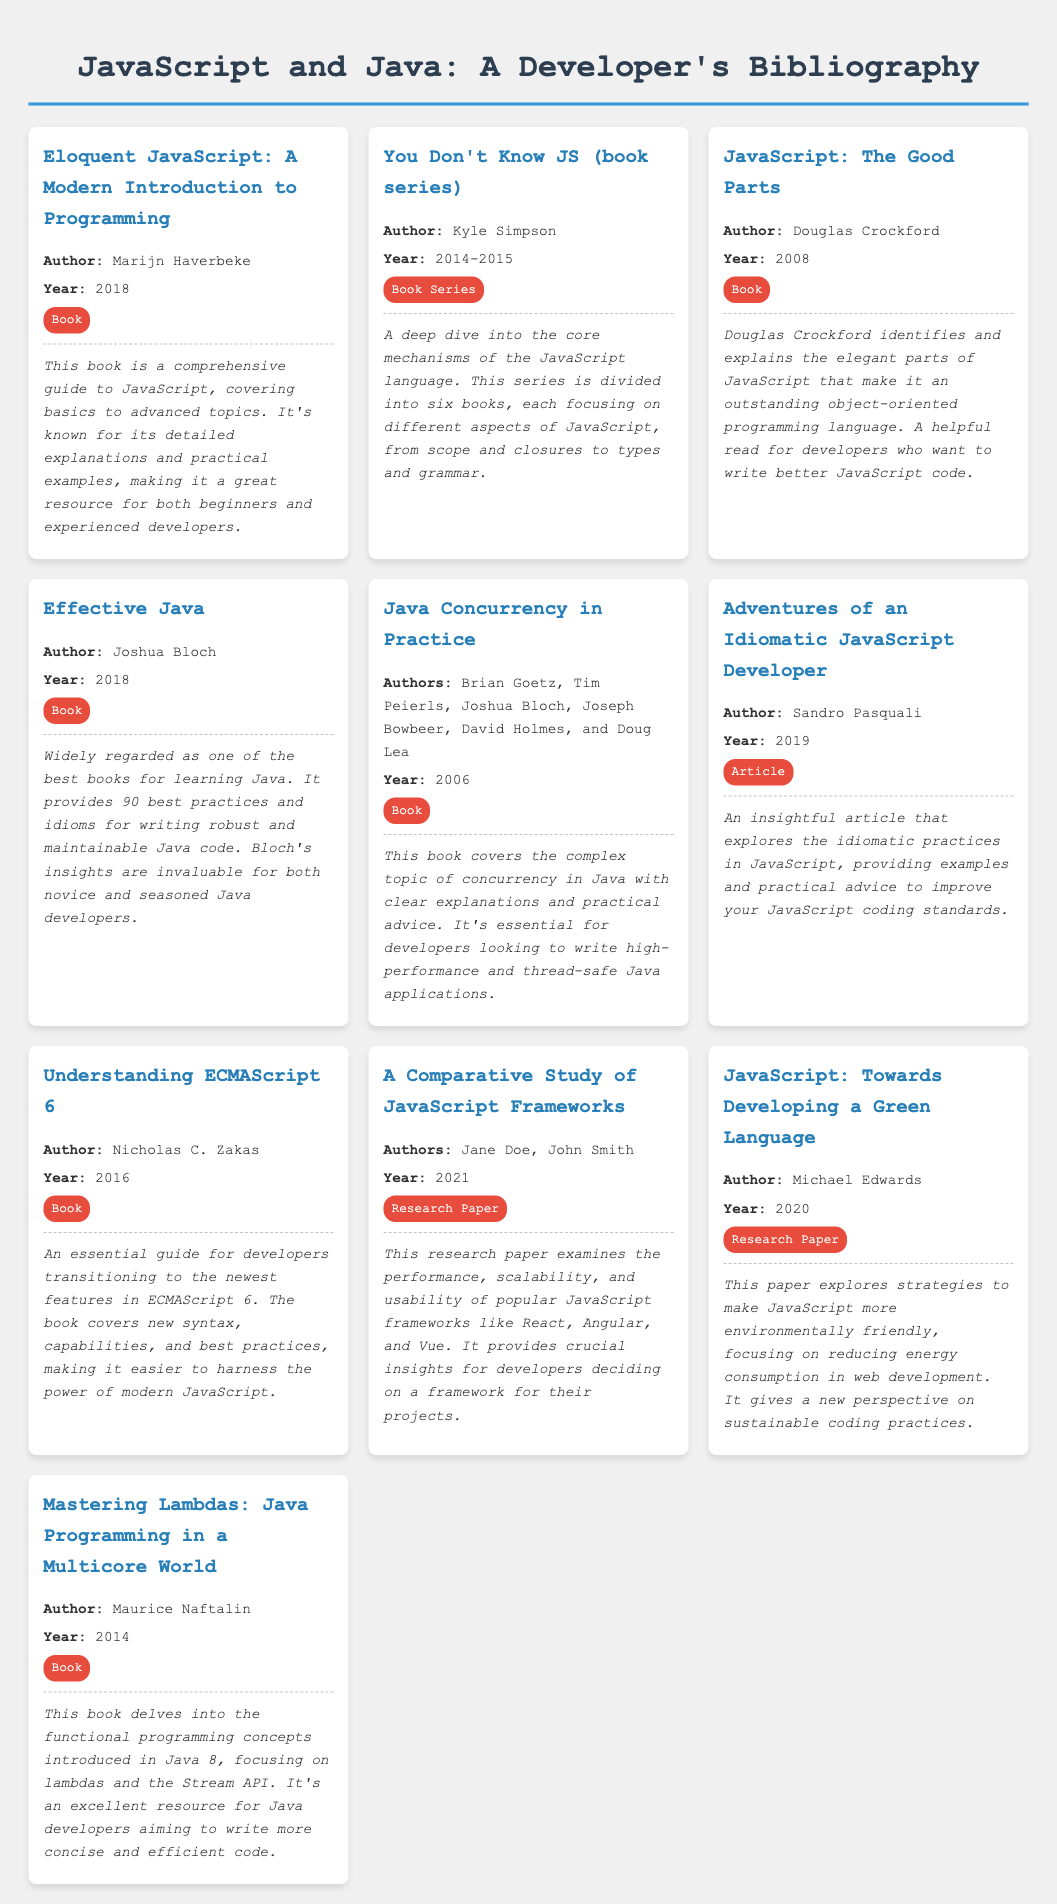What is the title of the book by Marijn Haverbeke? The document lists "Eloquent JavaScript: A Modern Introduction to Programming" as the title by Marijn Haverbeke.
Answer: Eloquent JavaScript: A Modern Introduction to Programming Who is the author of "Effective Java"? The document states that "Effective Java" is authored by Joshua Bloch.
Answer: Joshua Bloch What year was "JavaScript: The Good Parts" published? The document mentions that "JavaScript: The Good Parts" was published in 2008.
Answer: 2008 How many books are in the "You Don't Know JS" series? The document describes that the "You Don't Know JS" series is divided into six books.
Answer: Six Which book focuses on concurrency in Java? The document identifies "Java Concurrency in Practice" as the book that covers concurrency in Java.
Answer: Java Concurrency in Practice What type of document is "Adventures of an Idiomatic JavaScript Developer"? The document categorizes "Adventures of an Idiomatic JavaScript Developer" as an article.
Answer: Article What key topic does "Understanding ECMAScript 6" cover? The document indicates that "Understanding ECMAScript 6" covers new syntax, capabilities, and best practices in ECMAScript 6.
Answer: New syntax, capabilities, and best practices Who are the authors of the research paper titled "A Comparative Study of JavaScript Frameworks"? The document lists Jane Doe and John Smith as the authors of the research paper.
Answer: Jane Doe, John Smith Which author wrote about sustainable coding practices? The document mentions that Michael Edwards wrote about sustainable coding practices in "JavaScript: Towards Developing a Green Language".
Answer: Michael Edwards 